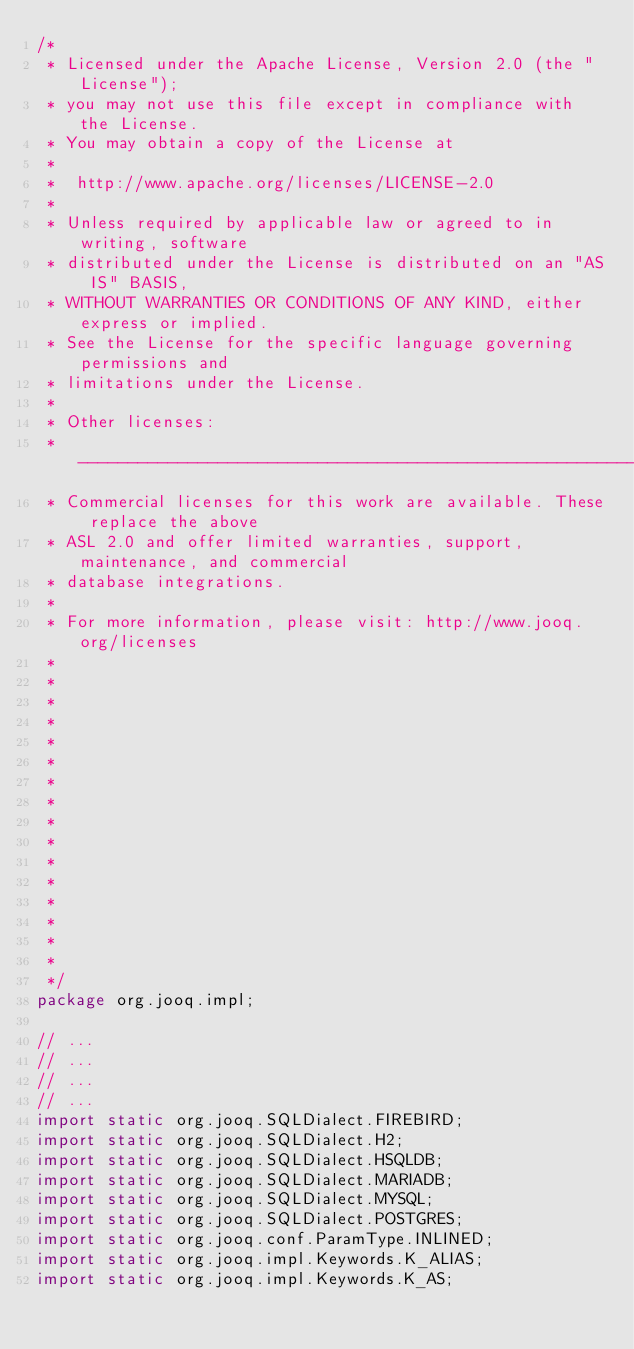Convert code to text. <code><loc_0><loc_0><loc_500><loc_500><_Java_>/* 
 * Licensed under the Apache License, Version 2.0 (the "License");
 * you may not use this file except in compliance with the License.
 * You may obtain a copy of the License at
 *
 *  http://www.apache.org/licenses/LICENSE-2.0
 *
 * Unless required by applicable law or agreed to in writing, software
 * distributed under the License is distributed on an "AS IS" BASIS,
 * WITHOUT WARRANTIES OR CONDITIONS OF ANY KIND, either express or implied.
 * See the License for the specific language governing permissions and
 * limitations under the License.
 *
 * Other licenses:
 * -----------------------------------------------------------------------------
 * Commercial licenses for this work are available. These replace the above
 * ASL 2.0 and offer limited warranties, support, maintenance, and commercial
 * database integrations.
 *
 * For more information, please visit: http://www.jooq.org/licenses
 *
 *
 *
 *
 *
 *
 *
 *
 *
 *
 *
 *
 *
 *
 *
 *
 */
package org.jooq.impl;

// ...
// ...
// ...
// ...
import static org.jooq.SQLDialect.FIREBIRD;
import static org.jooq.SQLDialect.H2;
import static org.jooq.SQLDialect.HSQLDB;
import static org.jooq.SQLDialect.MARIADB;
import static org.jooq.SQLDialect.MYSQL;
import static org.jooq.SQLDialect.POSTGRES;
import static org.jooq.conf.ParamType.INLINED;
import static org.jooq.impl.Keywords.K_ALIAS;
import static org.jooq.impl.Keywords.K_AS;</code> 